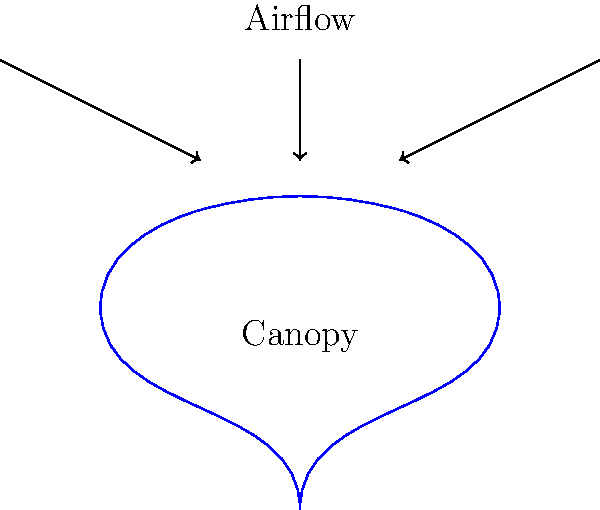As a Marine Corps veteran familiar with airborne operations, you understand the importance of parachute design. Consider a hemispherical parachute canopy with a diameter of 10 meters. If the parachute is descending at a steady velocity of 5 m/s in air with a density of 1.225 kg/m³, what is the approximate drag force (in Newtons) acting on the parachute? Assume a drag coefficient ($C_d$) of 1.75 for a hemispherical canopy. To solve this problem, we'll follow these steps:

1. Recall the drag force equation:
   $F_d = \frac{1}{2} \rho v^2 C_d A$

   Where:
   $F_d$ = Drag force (N)
   $\rho$ = Air density (kg/m³)
   $v$ = Velocity (m/s)
   $C_d$ = Drag coefficient
   $A$ = Projected area of the parachute (m²)

2. We're given:
   $\rho = 1.225$ kg/m³
   $v = 5$ m/s
   $C_d = 1.75$
   Diameter = 10 m

3. Calculate the projected area (A) of the hemispherical canopy:
   $A = \pi r^2 = \pi (5)^2 = 78.54$ m²

4. Substitute the values into the drag force equation:
   $F_d = \frac{1}{2} (1.225)(5^2)(1.75)(78.54)$

5. Calculate:
   $F_d = 0.5 * 1.225 * 25 * 1.75 * 78.54 = 1,677.9$ N

Therefore, the approximate drag force acting on the parachute is 1,678 N (rounded to the nearest whole number).
Answer: 1,678 N 